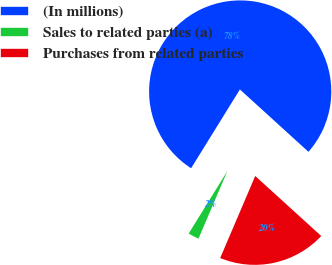Convert chart to OTSL. <chart><loc_0><loc_0><loc_500><loc_500><pie_chart><fcel>(In millions)<fcel>Sales to related parties (a)<fcel>Purchases from related parties<nl><fcel>77.93%<fcel>2.4%<fcel>19.68%<nl></chart> 